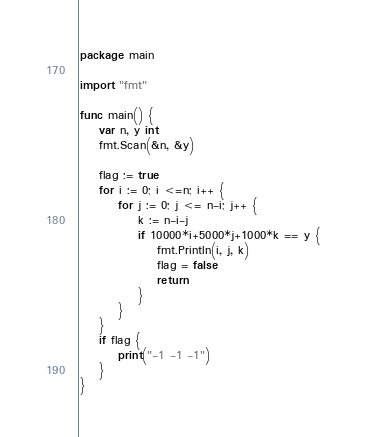Convert code to text. <code><loc_0><loc_0><loc_500><loc_500><_Go_>package main

import "fmt"

func main() {
	var n, y int
	fmt.Scan(&n, &y)

	flag := true
	for i := 0; i <=n; i++ {
		for j := 0; j <= n-i; j++ {
			k := n-i-j
			if 10000*i+5000*j+1000*k == y {
				fmt.Println(i, j, k)
				flag = false
				return
			}
		}
	}
	if flag {
		print("-1 -1 -1")
	}
}
</code> 